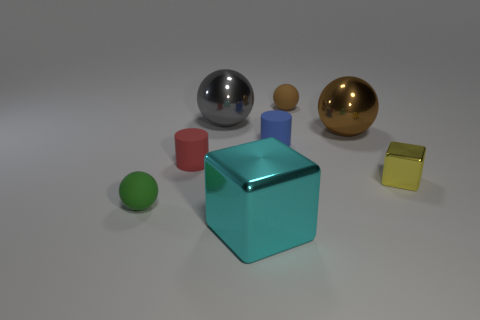Add 1 big gray cylinders. How many objects exist? 9 Subtract all cylinders. How many objects are left? 6 Add 6 matte spheres. How many matte spheres exist? 8 Subtract 1 cyan blocks. How many objects are left? 7 Subtract all tiny brown spheres. Subtract all large green cylinders. How many objects are left? 7 Add 7 large metallic blocks. How many large metallic blocks are left? 8 